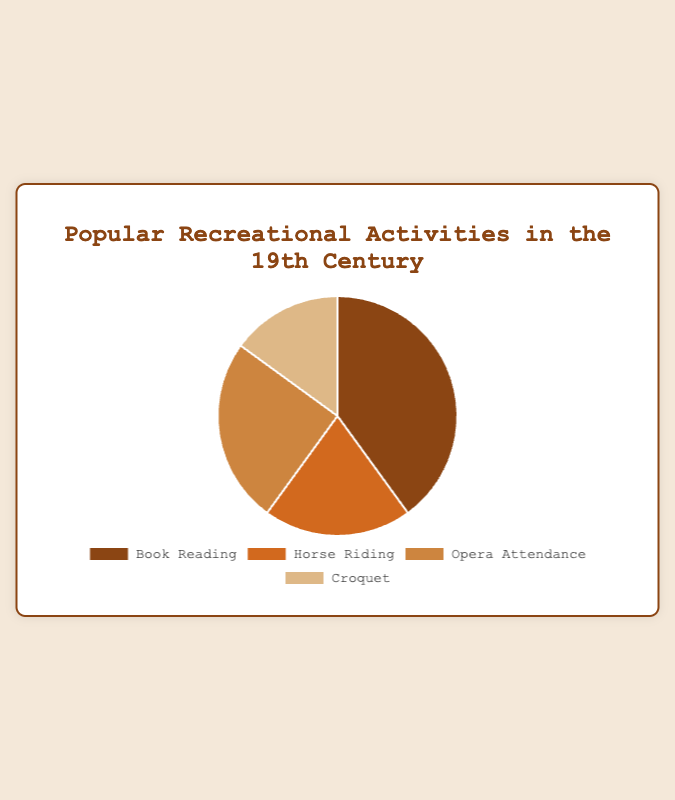What percentage of people preferred Book Reading? To determine the percentage of people who preferred Book Reading, simply refer to the segment labeled "Book Reading" in the pie chart. The label will indicate that this segment accounts for 40% of the total distribution.
Answer: 40% Which was more popular, Horse Riding or Croquet? Compare the percentages from the pie chart for Horse Riding and Croquet. Horse Riding has a larger segment at 20%, while Croquet has a smaller segment at 15%. Hence, Horse Riding was more popular.
Answer: Horse Riding What is the combined percentage of people who preferred Horse Riding and Opera Attendance? Add the percentages for Horse Riding and Opera Attendance from the pie chart. Horse Riding is 20% and Opera Attendance is 25%. The combined percentage is 20% + 25% = 45%.
Answer: 45% Which activity was the least popular? Look for the smallest segment in the pie chart. The segment labeled "Croquet" represents 15% of the total distribution, which is the smallest percentage among the activities.
Answer: Croquet What is the difference between the preference percentages of Book Reading and Opera Attendance? Subtract the percentage of Opera Attendance from the percentage of Book Reading. Book Reading is 40% and Opera Attendance is 25%. The difference is 40% - 25% = 15%.
Answer: 15% Is Book Reading more than twice as popular as Croquet? Compare twice the percentage of Croquet to the percentage of Book Reading. Twice the percentage of Croquet is 2 * 15% = 30%. Since Book Reading is 40%, which is more than 30%, Book Reading is indeed more than twice as popular as Croquet.
Answer: Yes How much more popular is Book Reading compared to Horse Riding? Subtract the percentage of Horse Riding from the percentage of Book Reading. Book Reading is 40% and Horse Riding is 20%. The difference is 40% - 20% = 20%.
Answer: 20% What is the average preference percentage of all the activities? Add the percentages of all activities and then divide by the number of activities. The percentages are 40%, 20%, 25%, and 15%. Sum them up: 40% + 20% + 25% + 15% = 100%. The average is 100% / 4 = 25%.
Answer: 25% What is the ratio of preference for Opera Attendance to Horse Riding? Divide the percentage of Opera Attendance by the percentage of Horse Riding. Opera Attendance is 25% and Horse Riding is 20%. The ratio is 25% / 20% = 1.25.
Answer: 1.25 What color represents Croquet in the pie chart? Examine the color-coded segments in the pie chart. The segment labeled "Croquet" is a light brown color.
Answer: light brown 